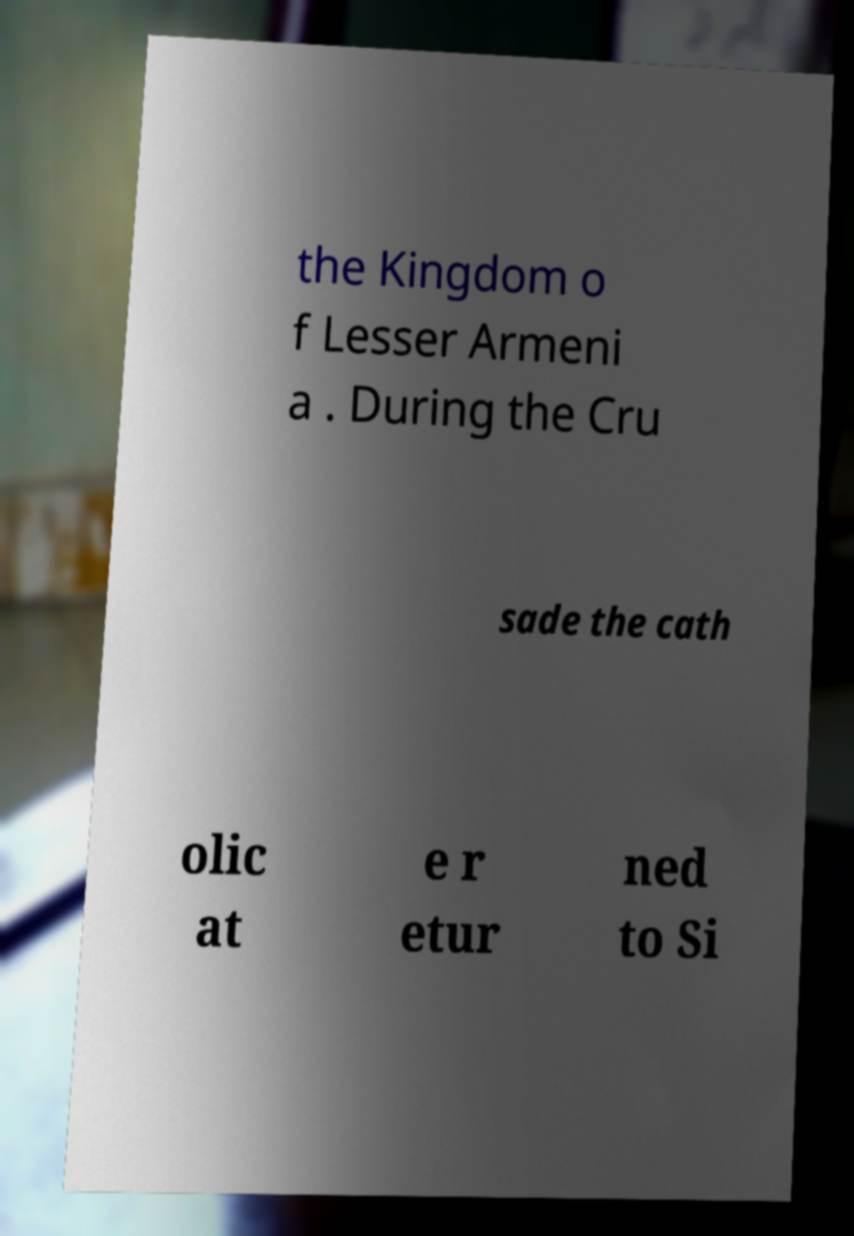Please identify and transcribe the text found in this image. the Kingdom o f Lesser Armeni a . During the Cru sade the cath olic at e r etur ned to Si 